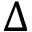Convert formula to latex. <formula><loc_0><loc_0><loc_500><loc_500>\Delta</formula> 